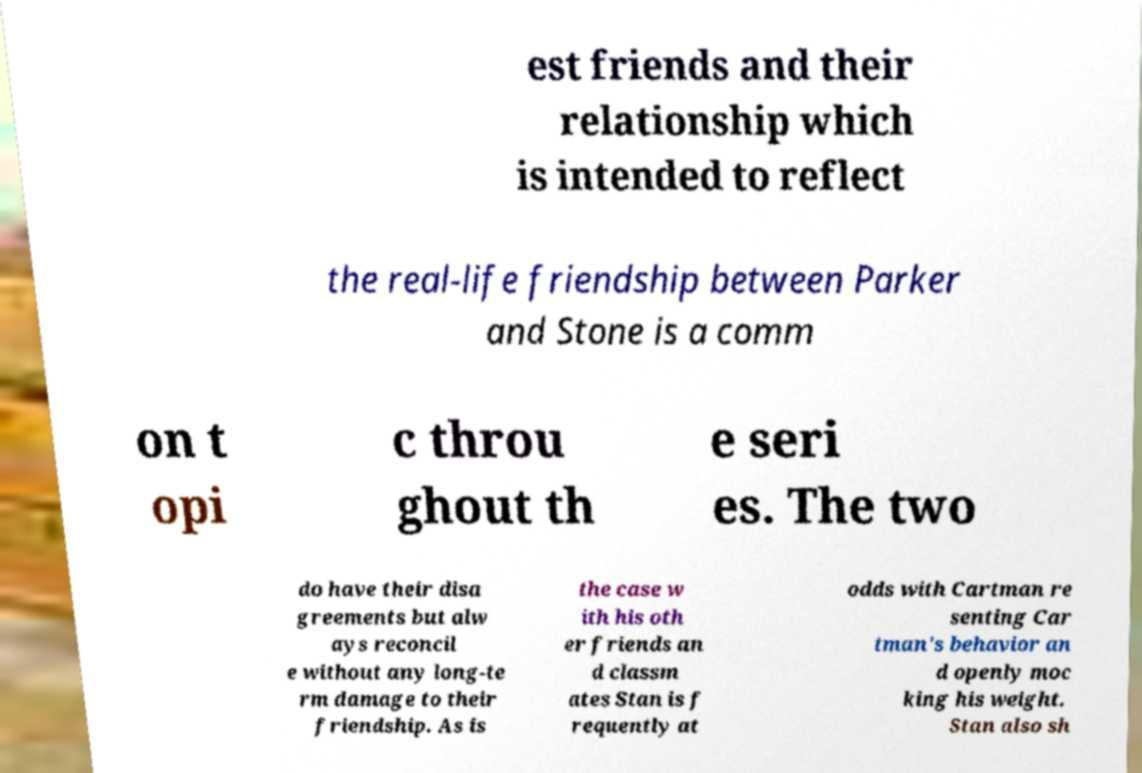Please identify and transcribe the text found in this image. est friends and their relationship which is intended to reflect the real-life friendship between Parker and Stone is a comm on t opi c throu ghout th e seri es. The two do have their disa greements but alw ays reconcil e without any long-te rm damage to their friendship. As is the case w ith his oth er friends an d classm ates Stan is f requently at odds with Cartman re senting Car tman's behavior an d openly moc king his weight. Stan also sh 